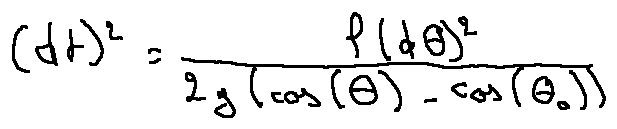Convert formula to latex. <formula><loc_0><loc_0><loc_500><loc_500>( d t ) ^ { 2 } = \frac { l ( d \theta ) ^ { 2 } } { 2 g ( \cos ( \theta ) - \cos ( \theta _ { 0 } ) ) }</formula> 